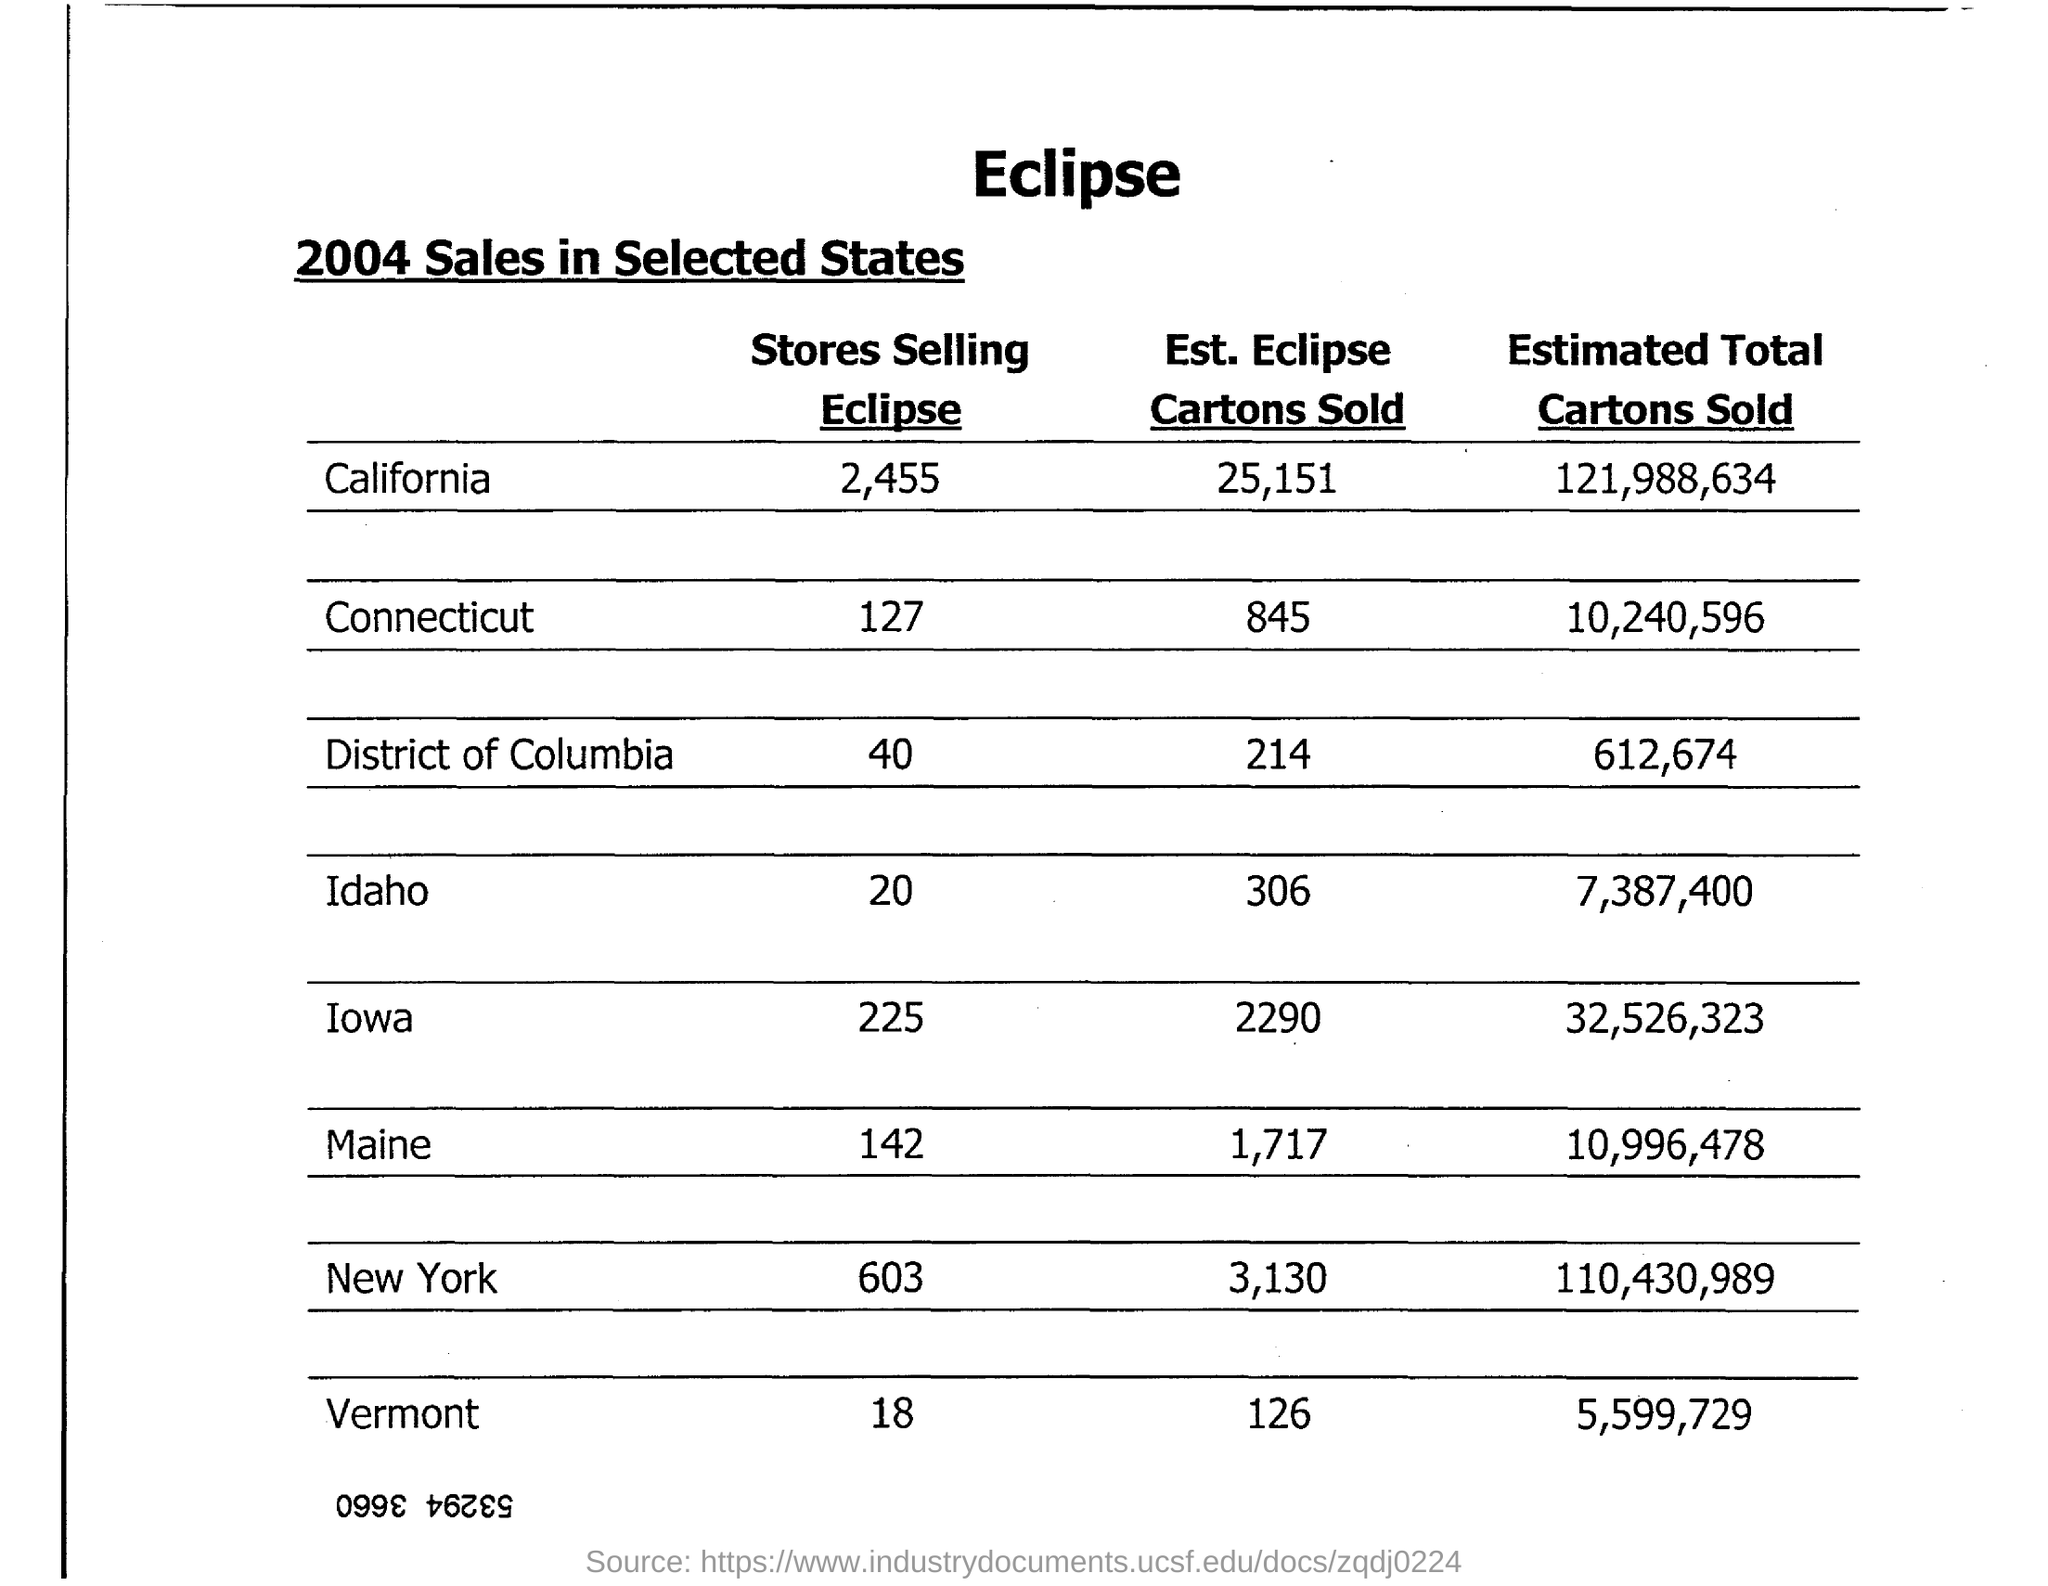What is the Est. Eclipse Cartons sold in California?
Keep it short and to the point. 25,151. What is the Estimated Total Cartons sold in Maine?
Keep it short and to the point. 10,996,478. What is the Est. Eclipse Cartons sold in idaho?
Provide a short and direct response. 306. What is the Estimated Total Cartons sold in Vermont?
Provide a short and direct response. 5,599,729. 